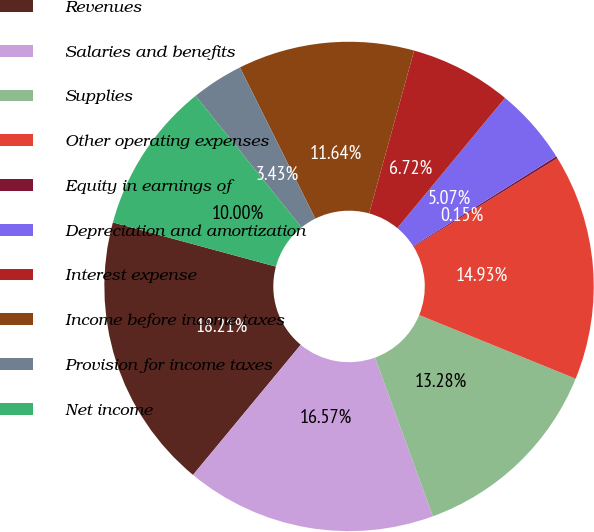<chart> <loc_0><loc_0><loc_500><loc_500><pie_chart><fcel>Revenues<fcel>Salaries and benefits<fcel>Supplies<fcel>Other operating expenses<fcel>Equity in earnings of<fcel>Depreciation and amortization<fcel>Interest expense<fcel>Income before income taxes<fcel>Provision for income taxes<fcel>Net income<nl><fcel>18.21%<fcel>16.57%<fcel>13.28%<fcel>14.93%<fcel>0.15%<fcel>5.07%<fcel>6.72%<fcel>11.64%<fcel>3.43%<fcel>10.0%<nl></chart> 